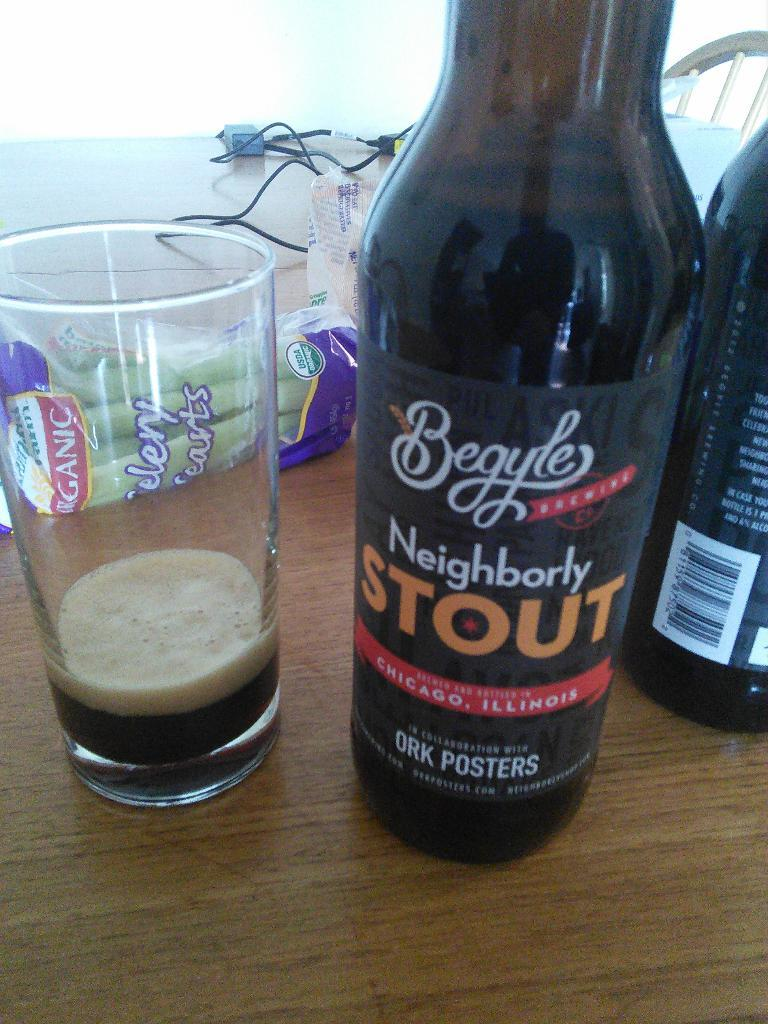Provide a one-sentence caption for the provided image. A bottle of Neighborly Stout drink sits beside a clear glass with a bit of the drink poured inside. 